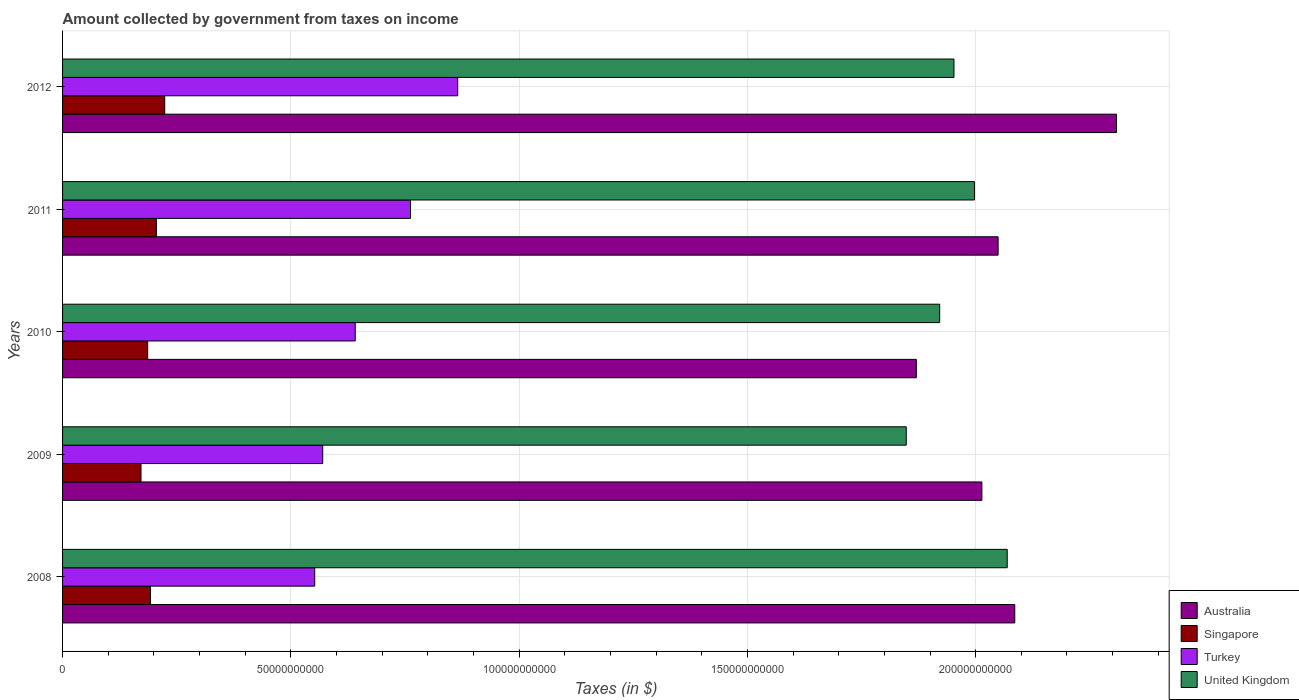Are the number of bars on each tick of the Y-axis equal?
Make the answer very short. Yes. How many bars are there on the 2nd tick from the top?
Make the answer very short. 4. How many bars are there on the 1st tick from the bottom?
Provide a short and direct response. 4. What is the label of the 1st group of bars from the top?
Make the answer very short. 2012. What is the amount collected by government from taxes on income in Turkey in 2012?
Your response must be concise. 8.66e+1. Across all years, what is the maximum amount collected by government from taxes on income in Turkey?
Your answer should be very brief. 8.66e+1. Across all years, what is the minimum amount collected by government from taxes on income in Singapore?
Your answer should be very brief. 1.72e+1. What is the total amount collected by government from taxes on income in United Kingdom in the graph?
Your answer should be compact. 9.79e+11. What is the difference between the amount collected by government from taxes on income in United Kingdom in 2008 and that in 2012?
Offer a very short reply. 1.17e+1. What is the difference between the amount collected by government from taxes on income in United Kingdom in 2010 and the amount collected by government from taxes on income in Turkey in 2012?
Keep it short and to the point. 1.06e+11. What is the average amount collected by government from taxes on income in Singapore per year?
Your response must be concise. 1.96e+1. In the year 2011, what is the difference between the amount collected by government from taxes on income in Turkey and amount collected by government from taxes on income in Australia?
Keep it short and to the point. -1.29e+11. In how many years, is the amount collected by government from taxes on income in Australia greater than 110000000000 $?
Provide a succinct answer. 5. What is the ratio of the amount collected by government from taxes on income in Turkey in 2009 to that in 2011?
Give a very brief answer. 0.75. Is the amount collected by government from taxes on income in United Kingdom in 2008 less than that in 2011?
Keep it short and to the point. No. What is the difference between the highest and the second highest amount collected by government from taxes on income in Singapore?
Give a very brief answer. 1.82e+09. What is the difference between the highest and the lowest amount collected by government from taxes on income in Turkey?
Provide a short and direct response. 3.13e+1. Is it the case that in every year, the sum of the amount collected by government from taxes on income in United Kingdom and amount collected by government from taxes on income in Singapore is greater than the sum of amount collected by government from taxes on income in Turkey and amount collected by government from taxes on income in Australia?
Your response must be concise. No. What does the 2nd bar from the bottom in 2010 represents?
Provide a succinct answer. Singapore. Are all the bars in the graph horizontal?
Offer a very short reply. Yes. What is the difference between two consecutive major ticks on the X-axis?
Give a very brief answer. 5.00e+1. Are the values on the major ticks of X-axis written in scientific E-notation?
Offer a terse response. No. Does the graph contain grids?
Offer a very short reply. Yes. Where does the legend appear in the graph?
Make the answer very short. Bottom right. How many legend labels are there?
Give a very brief answer. 4. What is the title of the graph?
Your answer should be very brief. Amount collected by government from taxes on income. What is the label or title of the X-axis?
Provide a succinct answer. Taxes (in $). What is the label or title of the Y-axis?
Make the answer very short. Years. What is the Taxes (in $) in Australia in 2008?
Provide a succinct answer. 2.09e+11. What is the Taxes (in $) of Singapore in 2008?
Provide a short and direct response. 1.93e+1. What is the Taxes (in $) in Turkey in 2008?
Offer a very short reply. 5.52e+1. What is the Taxes (in $) of United Kingdom in 2008?
Keep it short and to the point. 2.07e+11. What is the Taxes (in $) in Australia in 2009?
Make the answer very short. 2.01e+11. What is the Taxes (in $) of Singapore in 2009?
Provide a short and direct response. 1.72e+1. What is the Taxes (in $) in Turkey in 2009?
Offer a terse response. 5.70e+1. What is the Taxes (in $) in United Kingdom in 2009?
Your answer should be compact. 1.85e+11. What is the Taxes (in $) of Australia in 2010?
Your response must be concise. 1.87e+11. What is the Taxes (in $) in Singapore in 2010?
Provide a short and direct response. 1.86e+1. What is the Taxes (in $) of Turkey in 2010?
Your answer should be compact. 6.41e+1. What is the Taxes (in $) of United Kingdom in 2010?
Ensure brevity in your answer.  1.92e+11. What is the Taxes (in $) in Australia in 2011?
Your answer should be very brief. 2.05e+11. What is the Taxes (in $) of Singapore in 2011?
Your answer should be very brief. 2.06e+1. What is the Taxes (in $) of Turkey in 2011?
Offer a terse response. 7.62e+1. What is the Taxes (in $) in United Kingdom in 2011?
Offer a very short reply. 2.00e+11. What is the Taxes (in $) in Australia in 2012?
Make the answer very short. 2.31e+11. What is the Taxes (in $) in Singapore in 2012?
Make the answer very short. 2.24e+1. What is the Taxes (in $) in Turkey in 2012?
Provide a succinct answer. 8.66e+1. What is the Taxes (in $) in United Kingdom in 2012?
Give a very brief answer. 1.95e+11. Across all years, what is the maximum Taxes (in $) of Australia?
Keep it short and to the point. 2.31e+11. Across all years, what is the maximum Taxes (in $) in Singapore?
Offer a very short reply. 2.24e+1. Across all years, what is the maximum Taxes (in $) of Turkey?
Offer a very short reply. 8.66e+1. Across all years, what is the maximum Taxes (in $) of United Kingdom?
Ensure brevity in your answer.  2.07e+11. Across all years, what is the minimum Taxes (in $) in Australia?
Make the answer very short. 1.87e+11. Across all years, what is the minimum Taxes (in $) in Singapore?
Your answer should be very brief. 1.72e+1. Across all years, what is the minimum Taxes (in $) in Turkey?
Your answer should be very brief. 5.52e+1. Across all years, what is the minimum Taxes (in $) in United Kingdom?
Provide a short and direct response. 1.85e+11. What is the total Taxes (in $) in Australia in the graph?
Offer a terse response. 1.03e+12. What is the total Taxes (in $) of Singapore in the graph?
Offer a very short reply. 9.80e+1. What is the total Taxes (in $) of Turkey in the graph?
Ensure brevity in your answer.  3.39e+11. What is the total Taxes (in $) of United Kingdom in the graph?
Your answer should be compact. 9.79e+11. What is the difference between the Taxes (in $) of Australia in 2008 and that in 2009?
Give a very brief answer. 7.20e+09. What is the difference between the Taxes (in $) of Singapore in 2008 and that in 2009?
Your answer should be compact. 2.08e+09. What is the difference between the Taxes (in $) of Turkey in 2008 and that in 2009?
Your response must be concise. -1.75e+09. What is the difference between the Taxes (in $) in United Kingdom in 2008 and that in 2009?
Ensure brevity in your answer.  2.21e+1. What is the difference between the Taxes (in $) of Australia in 2008 and that in 2010?
Your answer should be compact. 2.16e+1. What is the difference between the Taxes (in $) in Singapore in 2008 and that in 2010?
Provide a succinct answer. 6.11e+08. What is the difference between the Taxes (in $) in Turkey in 2008 and that in 2010?
Offer a very short reply. -8.87e+09. What is the difference between the Taxes (in $) of United Kingdom in 2008 and that in 2010?
Your answer should be very brief. 1.48e+1. What is the difference between the Taxes (in $) of Australia in 2008 and that in 2011?
Offer a very short reply. 3.64e+09. What is the difference between the Taxes (in $) in Singapore in 2008 and that in 2011?
Your response must be concise. -1.30e+09. What is the difference between the Taxes (in $) in Turkey in 2008 and that in 2011?
Provide a short and direct response. -2.10e+1. What is the difference between the Taxes (in $) of United Kingdom in 2008 and that in 2011?
Your answer should be very brief. 7.18e+09. What is the difference between the Taxes (in $) in Australia in 2008 and that in 2012?
Keep it short and to the point. -2.23e+1. What is the difference between the Taxes (in $) in Singapore in 2008 and that in 2012?
Your response must be concise. -3.12e+09. What is the difference between the Taxes (in $) of Turkey in 2008 and that in 2012?
Give a very brief answer. -3.13e+1. What is the difference between the Taxes (in $) of United Kingdom in 2008 and that in 2012?
Provide a short and direct response. 1.17e+1. What is the difference between the Taxes (in $) of Australia in 2009 and that in 2010?
Offer a very short reply. 1.44e+1. What is the difference between the Taxes (in $) in Singapore in 2009 and that in 2010?
Your answer should be compact. -1.47e+09. What is the difference between the Taxes (in $) in Turkey in 2009 and that in 2010?
Provide a succinct answer. -7.12e+09. What is the difference between the Taxes (in $) in United Kingdom in 2009 and that in 2010?
Offer a terse response. -7.32e+09. What is the difference between the Taxes (in $) in Australia in 2009 and that in 2011?
Keep it short and to the point. -3.56e+09. What is the difference between the Taxes (in $) in Singapore in 2009 and that in 2011?
Ensure brevity in your answer.  -3.37e+09. What is the difference between the Taxes (in $) of Turkey in 2009 and that in 2011?
Ensure brevity in your answer.  -1.92e+1. What is the difference between the Taxes (in $) of United Kingdom in 2009 and that in 2011?
Keep it short and to the point. -1.49e+1. What is the difference between the Taxes (in $) of Australia in 2009 and that in 2012?
Give a very brief answer. -2.95e+1. What is the difference between the Taxes (in $) in Singapore in 2009 and that in 2012?
Your response must be concise. -5.20e+09. What is the difference between the Taxes (in $) of Turkey in 2009 and that in 2012?
Give a very brief answer. -2.96e+1. What is the difference between the Taxes (in $) in United Kingdom in 2009 and that in 2012?
Keep it short and to the point. -1.04e+1. What is the difference between the Taxes (in $) in Australia in 2010 and that in 2011?
Give a very brief answer. -1.79e+1. What is the difference between the Taxes (in $) of Singapore in 2010 and that in 2011?
Keep it short and to the point. -1.91e+09. What is the difference between the Taxes (in $) of Turkey in 2010 and that in 2011?
Provide a short and direct response. -1.21e+1. What is the difference between the Taxes (in $) in United Kingdom in 2010 and that in 2011?
Your answer should be compact. -7.62e+09. What is the difference between the Taxes (in $) in Australia in 2010 and that in 2012?
Your response must be concise. -4.38e+1. What is the difference between the Taxes (in $) of Singapore in 2010 and that in 2012?
Make the answer very short. -3.73e+09. What is the difference between the Taxes (in $) in Turkey in 2010 and that in 2012?
Keep it short and to the point. -2.25e+1. What is the difference between the Taxes (in $) of United Kingdom in 2010 and that in 2012?
Ensure brevity in your answer.  -3.13e+09. What is the difference between the Taxes (in $) of Australia in 2011 and that in 2012?
Ensure brevity in your answer.  -2.59e+1. What is the difference between the Taxes (in $) of Singapore in 2011 and that in 2012?
Keep it short and to the point. -1.82e+09. What is the difference between the Taxes (in $) in Turkey in 2011 and that in 2012?
Give a very brief answer. -1.03e+1. What is the difference between the Taxes (in $) of United Kingdom in 2011 and that in 2012?
Offer a very short reply. 4.49e+09. What is the difference between the Taxes (in $) of Australia in 2008 and the Taxes (in $) of Singapore in 2009?
Offer a terse response. 1.91e+11. What is the difference between the Taxes (in $) in Australia in 2008 and the Taxes (in $) in Turkey in 2009?
Ensure brevity in your answer.  1.52e+11. What is the difference between the Taxes (in $) in Australia in 2008 and the Taxes (in $) in United Kingdom in 2009?
Your answer should be compact. 2.38e+1. What is the difference between the Taxes (in $) of Singapore in 2008 and the Taxes (in $) of Turkey in 2009?
Offer a very short reply. -3.77e+1. What is the difference between the Taxes (in $) of Singapore in 2008 and the Taxes (in $) of United Kingdom in 2009?
Ensure brevity in your answer.  -1.66e+11. What is the difference between the Taxes (in $) in Turkey in 2008 and the Taxes (in $) in United Kingdom in 2009?
Offer a very short reply. -1.30e+11. What is the difference between the Taxes (in $) of Australia in 2008 and the Taxes (in $) of Singapore in 2010?
Your response must be concise. 1.90e+11. What is the difference between the Taxes (in $) in Australia in 2008 and the Taxes (in $) in Turkey in 2010?
Keep it short and to the point. 1.44e+11. What is the difference between the Taxes (in $) in Australia in 2008 and the Taxes (in $) in United Kingdom in 2010?
Your response must be concise. 1.64e+1. What is the difference between the Taxes (in $) of Singapore in 2008 and the Taxes (in $) of Turkey in 2010?
Provide a short and direct response. -4.48e+1. What is the difference between the Taxes (in $) of Singapore in 2008 and the Taxes (in $) of United Kingdom in 2010?
Provide a short and direct response. -1.73e+11. What is the difference between the Taxes (in $) in Turkey in 2008 and the Taxes (in $) in United Kingdom in 2010?
Make the answer very short. -1.37e+11. What is the difference between the Taxes (in $) in Australia in 2008 and the Taxes (in $) in Singapore in 2011?
Give a very brief answer. 1.88e+11. What is the difference between the Taxes (in $) of Australia in 2008 and the Taxes (in $) of Turkey in 2011?
Your answer should be compact. 1.32e+11. What is the difference between the Taxes (in $) in Australia in 2008 and the Taxes (in $) in United Kingdom in 2011?
Offer a terse response. 8.83e+09. What is the difference between the Taxes (in $) in Singapore in 2008 and the Taxes (in $) in Turkey in 2011?
Your answer should be very brief. -5.70e+1. What is the difference between the Taxes (in $) of Singapore in 2008 and the Taxes (in $) of United Kingdom in 2011?
Offer a terse response. -1.80e+11. What is the difference between the Taxes (in $) of Turkey in 2008 and the Taxes (in $) of United Kingdom in 2011?
Your response must be concise. -1.45e+11. What is the difference between the Taxes (in $) in Australia in 2008 and the Taxes (in $) in Singapore in 2012?
Provide a short and direct response. 1.86e+11. What is the difference between the Taxes (in $) of Australia in 2008 and the Taxes (in $) of Turkey in 2012?
Your answer should be very brief. 1.22e+11. What is the difference between the Taxes (in $) in Australia in 2008 and the Taxes (in $) in United Kingdom in 2012?
Provide a succinct answer. 1.33e+1. What is the difference between the Taxes (in $) of Singapore in 2008 and the Taxes (in $) of Turkey in 2012?
Offer a terse response. -6.73e+1. What is the difference between the Taxes (in $) of Singapore in 2008 and the Taxes (in $) of United Kingdom in 2012?
Provide a short and direct response. -1.76e+11. What is the difference between the Taxes (in $) in Turkey in 2008 and the Taxes (in $) in United Kingdom in 2012?
Offer a very short reply. -1.40e+11. What is the difference between the Taxes (in $) in Australia in 2009 and the Taxes (in $) in Singapore in 2010?
Ensure brevity in your answer.  1.83e+11. What is the difference between the Taxes (in $) of Australia in 2009 and the Taxes (in $) of Turkey in 2010?
Your answer should be compact. 1.37e+11. What is the difference between the Taxes (in $) in Australia in 2009 and the Taxes (in $) in United Kingdom in 2010?
Provide a succinct answer. 9.25e+09. What is the difference between the Taxes (in $) of Singapore in 2009 and the Taxes (in $) of Turkey in 2010?
Offer a very short reply. -4.69e+1. What is the difference between the Taxes (in $) of Singapore in 2009 and the Taxes (in $) of United Kingdom in 2010?
Keep it short and to the point. -1.75e+11. What is the difference between the Taxes (in $) of Turkey in 2009 and the Taxes (in $) of United Kingdom in 2010?
Make the answer very short. -1.35e+11. What is the difference between the Taxes (in $) of Australia in 2009 and the Taxes (in $) of Singapore in 2011?
Provide a succinct answer. 1.81e+11. What is the difference between the Taxes (in $) in Australia in 2009 and the Taxes (in $) in Turkey in 2011?
Make the answer very short. 1.25e+11. What is the difference between the Taxes (in $) of Australia in 2009 and the Taxes (in $) of United Kingdom in 2011?
Offer a terse response. 1.63e+09. What is the difference between the Taxes (in $) of Singapore in 2009 and the Taxes (in $) of Turkey in 2011?
Provide a succinct answer. -5.90e+1. What is the difference between the Taxes (in $) in Singapore in 2009 and the Taxes (in $) in United Kingdom in 2011?
Make the answer very short. -1.83e+11. What is the difference between the Taxes (in $) in Turkey in 2009 and the Taxes (in $) in United Kingdom in 2011?
Ensure brevity in your answer.  -1.43e+11. What is the difference between the Taxes (in $) of Australia in 2009 and the Taxes (in $) of Singapore in 2012?
Make the answer very short. 1.79e+11. What is the difference between the Taxes (in $) in Australia in 2009 and the Taxes (in $) in Turkey in 2012?
Keep it short and to the point. 1.15e+11. What is the difference between the Taxes (in $) of Australia in 2009 and the Taxes (in $) of United Kingdom in 2012?
Your response must be concise. 6.12e+09. What is the difference between the Taxes (in $) in Singapore in 2009 and the Taxes (in $) in Turkey in 2012?
Provide a short and direct response. -6.94e+1. What is the difference between the Taxes (in $) in Singapore in 2009 and the Taxes (in $) in United Kingdom in 2012?
Provide a short and direct response. -1.78e+11. What is the difference between the Taxes (in $) in Turkey in 2009 and the Taxes (in $) in United Kingdom in 2012?
Keep it short and to the point. -1.38e+11. What is the difference between the Taxes (in $) of Australia in 2010 and the Taxes (in $) of Singapore in 2011?
Ensure brevity in your answer.  1.66e+11. What is the difference between the Taxes (in $) of Australia in 2010 and the Taxes (in $) of Turkey in 2011?
Provide a short and direct response. 1.11e+11. What is the difference between the Taxes (in $) of Australia in 2010 and the Taxes (in $) of United Kingdom in 2011?
Ensure brevity in your answer.  -1.27e+1. What is the difference between the Taxes (in $) in Singapore in 2010 and the Taxes (in $) in Turkey in 2011?
Your response must be concise. -5.76e+1. What is the difference between the Taxes (in $) in Singapore in 2010 and the Taxes (in $) in United Kingdom in 2011?
Offer a very short reply. -1.81e+11. What is the difference between the Taxes (in $) of Turkey in 2010 and the Taxes (in $) of United Kingdom in 2011?
Your answer should be very brief. -1.36e+11. What is the difference between the Taxes (in $) of Australia in 2010 and the Taxes (in $) of Singapore in 2012?
Make the answer very short. 1.65e+11. What is the difference between the Taxes (in $) of Australia in 2010 and the Taxes (in $) of Turkey in 2012?
Provide a succinct answer. 1.00e+11. What is the difference between the Taxes (in $) of Australia in 2010 and the Taxes (in $) of United Kingdom in 2012?
Give a very brief answer. -8.24e+09. What is the difference between the Taxes (in $) of Singapore in 2010 and the Taxes (in $) of Turkey in 2012?
Give a very brief answer. -6.79e+1. What is the difference between the Taxes (in $) in Singapore in 2010 and the Taxes (in $) in United Kingdom in 2012?
Keep it short and to the point. -1.77e+11. What is the difference between the Taxes (in $) in Turkey in 2010 and the Taxes (in $) in United Kingdom in 2012?
Provide a succinct answer. -1.31e+11. What is the difference between the Taxes (in $) in Australia in 2011 and the Taxes (in $) in Singapore in 2012?
Your response must be concise. 1.83e+11. What is the difference between the Taxes (in $) in Australia in 2011 and the Taxes (in $) in Turkey in 2012?
Give a very brief answer. 1.18e+11. What is the difference between the Taxes (in $) in Australia in 2011 and the Taxes (in $) in United Kingdom in 2012?
Keep it short and to the point. 9.67e+09. What is the difference between the Taxes (in $) of Singapore in 2011 and the Taxes (in $) of Turkey in 2012?
Give a very brief answer. -6.60e+1. What is the difference between the Taxes (in $) in Singapore in 2011 and the Taxes (in $) in United Kingdom in 2012?
Provide a short and direct response. -1.75e+11. What is the difference between the Taxes (in $) of Turkey in 2011 and the Taxes (in $) of United Kingdom in 2012?
Provide a short and direct response. -1.19e+11. What is the average Taxes (in $) of Australia per year?
Ensure brevity in your answer.  2.07e+11. What is the average Taxes (in $) of Singapore per year?
Offer a very short reply. 1.96e+1. What is the average Taxes (in $) of Turkey per year?
Your response must be concise. 6.78e+1. What is the average Taxes (in $) in United Kingdom per year?
Offer a very short reply. 1.96e+11. In the year 2008, what is the difference between the Taxes (in $) of Australia and Taxes (in $) of Singapore?
Ensure brevity in your answer.  1.89e+11. In the year 2008, what is the difference between the Taxes (in $) in Australia and Taxes (in $) in Turkey?
Provide a short and direct response. 1.53e+11. In the year 2008, what is the difference between the Taxes (in $) in Australia and Taxes (in $) in United Kingdom?
Provide a short and direct response. 1.65e+09. In the year 2008, what is the difference between the Taxes (in $) of Singapore and Taxes (in $) of Turkey?
Provide a short and direct response. -3.60e+1. In the year 2008, what is the difference between the Taxes (in $) of Singapore and Taxes (in $) of United Kingdom?
Provide a short and direct response. -1.88e+11. In the year 2008, what is the difference between the Taxes (in $) in Turkey and Taxes (in $) in United Kingdom?
Offer a very short reply. -1.52e+11. In the year 2009, what is the difference between the Taxes (in $) in Australia and Taxes (in $) in Singapore?
Keep it short and to the point. 1.84e+11. In the year 2009, what is the difference between the Taxes (in $) of Australia and Taxes (in $) of Turkey?
Keep it short and to the point. 1.44e+11. In the year 2009, what is the difference between the Taxes (in $) of Australia and Taxes (in $) of United Kingdom?
Keep it short and to the point. 1.66e+1. In the year 2009, what is the difference between the Taxes (in $) of Singapore and Taxes (in $) of Turkey?
Make the answer very short. -3.98e+1. In the year 2009, what is the difference between the Taxes (in $) in Singapore and Taxes (in $) in United Kingdom?
Give a very brief answer. -1.68e+11. In the year 2009, what is the difference between the Taxes (in $) of Turkey and Taxes (in $) of United Kingdom?
Provide a succinct answer. -1.28e+11. In the year 2010, what is the difference between the Taxes (in $) of Australia and Taxes (in $) of Singapore?
Your answer should be very brief. 1.68e+11. In the year 2010, what is the difference between the Taxes (in $) in Australia and Taxes (in $) in Turkey?
Make the answer very short. 1.23e+11. In the year 2010, what is the difference between the Taxes (in $) in Australia and Taxes (in $) in United Kingdom?
Offer a terse response. -5.12e+09. In the year 2010, what is the difference between the Taxes (in $) in Singapore and Taxes (in $) in Turkey?
Offer a terse response. -4.55e+1. In the year 2010, what is the difference between the Taxes (in $) of Singapore and Taxes (in $) of United Kingdom?
Keep it short and to the point. -1.73e+11. In the year 2010, what is the difference between the Taxes (in $) in Turkey and Taxes (in $) in United Kingdom?
Keep it short and to the point. -1.28e+11. In the year 2011, what is the difference between the Taxes (in $) of Australia and Taxes (in $) of Singapore?
Your answer should be very brief. 1.84e+11. In the year 2011, what is the difference between the Taxes (in $) of Australia and Taxes (in $) of Turkey?
Keep it short and to the point. 1.29e+11. In the year 2011, what is the difference between the Taxes (in $) of Australia and Taxes (in $) of United Kingdom?
Give a very brief answer. 5.18e+09. In the year 2011, what is the difference between the Taxes (in $) of Singapore and Taxes (in $) of Turkey?
Your answer should be compact. -5.57e+1. In the year 2011, what is the difference between the Taxes (in $) in Singapore and Taxes (in $) in United Kingdom?
Give a very brief answer. -1.79e+11. In the year 2011, what is the difference between the Taxes (in $) in Turkey and Taxes (in $) in United Kingdom?
Offer a terse response. -1.24e+11. In the year 2012, what is the difference between the Taxes (in $) of Australia and Taxes (in $) of Singapore?
Offer a terse response. 2.08e+11. In the year 2012, what is the difference between the Taxes (in $) of Australia and Taxes (in $) of Turkey?
Ensure brevity in your answer.  1.44e+11. In the year 2012, what is the difference between the Taxes (in $) of Australia and Taxes (in $) of United Kingdom?
Make the answer very short. 3.56e+1. In the year 2012, what is the difference between the Taxes (in $) in Singapore and Taxes (in $) in Turkey?
Your response must be concise. -6.42e+1. In the year 2012, what is the difference between the Taxes (in $) of Singapore and Taxes (in $) of United Kingdom?
Your response must be concise. -1.73e+11. In the year 2012, what is the difference between the Taxes (in $) of Turkey and Taxes (in $) of United Kingdom?
Offer a terse response. -1.09e+11. What is the ratio of the Taxes (in $) in Australia in 2008 to that in 2009?
Keep it short and to the point. 1.04. What is the ratio of the Taxes (in $) in Singapore in 2008 to that in 2009?
Give a very brief answer. 1.12. What is the ratio of the Taxes (in $) of Turkey in 2008 to that in 2009?
Make the answer very short. 0.97. What is the ratio of the Taxes (in $) in United Kingdom in 2008 to that in 2009?
Your response must be concise. 1.12. What is the ratio of the Taxes (in $) of Australia in 2008 to that in 2010?
Provide a succinct answer. 1.12. What is the ratio of the Taxes (in $) in Singapore in 2008 to that in 2010?
Provide a short and direct response. 1.03. What is the ratio of the Taxes (in $) of Turkey in 2008 to that in 2010?
Provide a succinct answer. 0.86. What is the ratio of the Taxes (in $) in United Kingdom in 2008 to that in 2010?
Provide a succinct answer. 1.08. What is the ratio of the Taxes (in $) of Australia in 2008 to that in 2011?
Your answer should be compact. 1.02. What is the ratio of the Taxes (in $) in Singapore in 2008 to that in 2011?
Your answer should be compact. 0.94. What is the ratio of the Taxes (in $) of Turkey in 2008 to that in 2011?
Provide a succinct answer. 0.72. What is the ratio of the Taxes (in $) of United Kingdom in 2008 to that in 2011?
Give a very brief answer. 1.04. What is the ratio of the Taxes (in $) of Australia in 2008 to that in 2012?
Keep it short and to the point. 0.9. What is the ratio of the Taxes (in $) in Singapore in 2008 to that in 2012?
Provide a short and direct response. 0.86. What is the ratio of the Taxes (in $) of Turkey in 2008 to that in 2012?
Offer a very short reply. 0.64. What is the ratio of the Taxes (in $) of United Kingdom in 2008 to that in 2012?
Ensure brevity in your answer.  1.06. What is the ratio of the Taxes (in $) in Australia in 2009 to that in 2010?
Keep it short and to the point. 1.08. What is the ratio of the Taxes (in $) in Singapore in 2009 to that in 2010?
Offer a very short reply. 0.92. What is the ratio of the Taxes (in $) in United Kingdom in 2009 to that in 2010?
Make the answer very short. 0.96. What is the ratio of the Taxes (in $) of Australia in 2009 to that in 2011?
Provide a succinct answer. 0.98. What is the ratio of the Taxes (in $) of Singapore in 2009 to that in 2011?
Ensure brevity in your answer.  0.84. What is the ratio of the Taxes (in $) in Turkey in 2009 to that in 2011?
Your answer should be compact. 0.75. What is the ratio of the Taxes (in $) in United Kingdom in 2009 to that in 2011?
Provide a succinct answer. 0.93. What is the ratio of the Taxes (in $) of Australia in 2009 to that in 2012?
Provide a short and direct response. 0.87. What is the ratio of the Taxes (in $) of Singapore in 2009 to that in 2012?
Ensure brevity in your answer.  0.77. What is the ratio of the Taxes (in $) in Turkey in 2009 to that in 2012?
Ensure brevity in your answer.  0.66. What is the ratio of the Taxes (in $) in United Kingdom in 2009 to that in 2012?
Make the answer very short. 0.95. What is the ratio of the Taxes (in $) of Australia in 2010 to that in 2011?
Keep it short and to the point. 0.91. What is the ratio of the Taxes (in $) in Singapore in 2010 to that in 2011?
Provide a succinct answer. 0.91. What is the ratio of the Taxes (in $) of Turkey in 2010 to that in 2011?
Ensure brevity in your answer.  0.84. What is the ratio of the Taxes (in $) of United Kingdom in 2010 to that in 2011?
Provide a short and direct response. 0.96. What is the ratio of the Taxes (in $) in Australia in 2010 to that in 2012?
Your answer should be very brief. 0.81. What is the ratio of the Taxes (in $) of Singapore in 2010 to that in 2012?
Your answer should be compact. 0.83. What is the ratio of the Taxes (in $) of Turkey in 2010 to that in 2012?
Ensure brevity in your answer.  0.74. What is the ratio of the Taxes (in $) of Australia in 2011 to that in 2012?
Provide a short and direct response. 0.89. What is the ratio of the Taxes (in $) in Singapore in 2011 to that in 2012?
Your answer should be very brief. 0.92. What is the ratio of the Taxes (in $) of Turkey in 2011 to that in 2012?
Offer a very short reply. 0.88. What is the ratio of the Taxes (in $) of United Kingdom in 2011 to that in 2012?
Ensure brevity in your answer.  1.02. What is the difference between the highest and the second highest Taxes (in $) in Australia?
Offer a terse response. 2.23e+1. What is the difference between the highest and the second highest Taxes (in $) of Singapore?
Provide a succinct answer. 1.82e+09. What is the difference between the highest and the second highest Taxes (in $) of Turkey?
Provide a short and direct response. 1.03e+1. What is the difference between the highest and the second highest Taxes (in $) in United Kingdom?
Your answer should be very brief. 7.18e+09. What is the difference between the highest and the lowest Taxes (in $) of Australia?
Your answer should be very brief. 4.38e+1. What is the difference between the highest and the lowest Taxes (in $) in Singapore?
Ensure brevity in your answer.  5.20e+09. What is the difference between the highest and the lowest Taxes (in $) of Turkey?
Offer a terse response. 3.13e+1. What is the difference between the highest and the lowest Taxes (in $) in United Kingdom?
Your answer should be compact. 2.21e+1. 